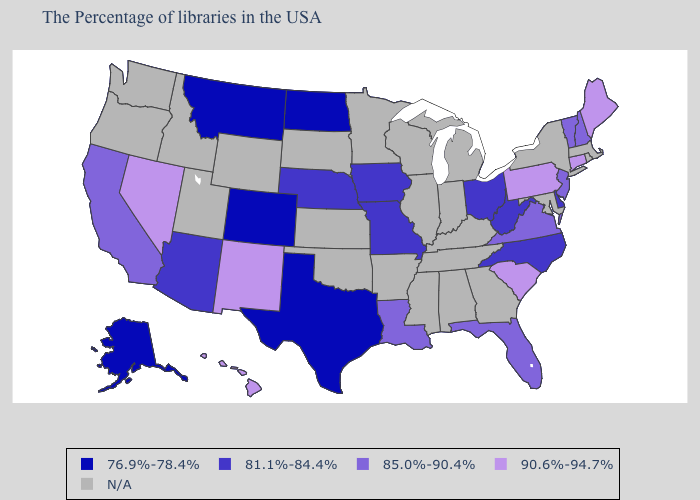How many symbols are there in the legend?
Give a very brief answer. 5. Does Florida have the highest value in the South?
Answer briefly. No. What is the highest value in states that border Arkansas?
Keep it brief. 85.0%-90.4%. Which states hav the highest value in the MidWest?
Write a very short answer. Ohio, Missouri, Iowa, Nebraska. Does the map have missing data?
Short answer required. Yes. What is the highest value in the USA?
Give a very brief answer. 90.6%-94.7%. Does Florida have the highest value in the USA?
Be succinct. No. Does the first symbol in the legend represent the smallest category?
Concise answer only. Yes. Does New Hampshire have the highest value in the Northeast?
Answer briefly. No. Which states have the lowest value in the USA?
Write a very short answer. Texas, North Dakota, Colorado, Montana, Alaska. Which states have the lowest value in the West?
Answer briefly. Colorado, Montana, Alaska. Name the states that have a value in the range 90.6%-94.7%?
Quick response, please. Maine, Connecticut, Pennsylvania, South Carolina, New Mexico, Nevada, Hawaii. 